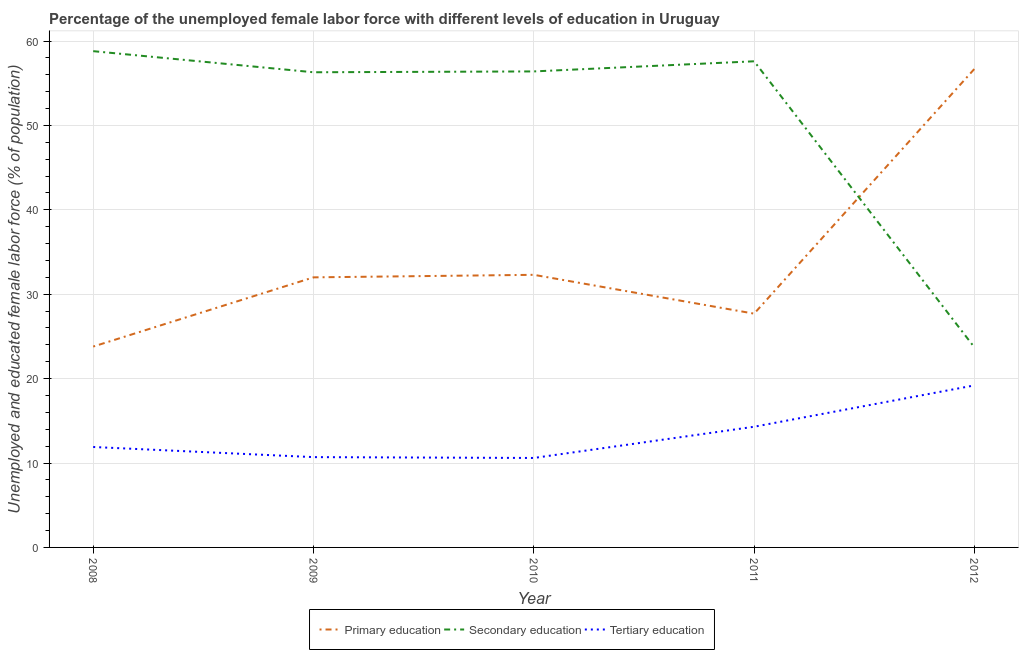How many different coloured lines are there?
Offer a terse response. 3. Does the line corresponding to percentage of female labor force who received primary education intersect with the line corresponding to percentage of female labor force who received secondary education?
Provide a succinct answer. Yes. What is the percentage of female labor force who received primary education in 2010?
Your answer should be compact. 32.3. Across all years, what is the maximum percentage of female labor force who received tertiary education?
Offer a terse response. 19.2. Across all years, what is the minimum percentage of female labor force who received secondary education?
Provide a succinct answer. 23.7. In which year was the percentage of female labor force who received primary education maximum?
Give a very brief answer. 2012. In which year was the percentage of female labor force who received secondary education minimum?
Provide a short and direct response. 2012. What is the total percentage of female labor force who received secondary education in the graph?
Your answer should be very brief. 252.8. What is the difference between the percentage of female labor force who received tertiary education in 2010 and that in 2012?
Your answer should be very brief. -8.6. What is the difference between the percentage of female labor force who received primary education in 2012 and the percentage of female labor force who received secondary education in 2009?
Provide a succinct answer. 0.4. What is the average percentage of female labor force who received primary education per year?
Provide a short and direct response. 34.5. In the year 2011, what is the difference between the percentage of female labor force who received secondary education and percentage of female labor force who received tertiary education?
Provide a short and direct response. 43.3. In how many years, is the percentage of female labor force who received primary education greater than 20 %?
Your answer should be very brief. 5. What is the ratio of the percentage of female labor force who received tertiary education in 2008 to that in 2009?
Provide a short and direct response. 1.11. Is the difference between the percentage of female labor force who received tertiary education in 2008 and 2009 greater than the difference between the percentage of female labor force who received secondary education in 2008 and 2009?
Make the answer very short. No. What is the difference between the highest and the second highest percentage of female labor force who received primary education?
Provide a short and direct response. 24.4. What is the difference between the highest and the lowest percentage of female labor force who received secondary education?
Keep it short and to the point. 35.1. How many lines are there?
Your response must be concise. 3. How many years are there in the graph?
Keep it short and to the point. 5. Are the values on the major ticks of Y-axis written in scientific E-notation?
Make the answer very short. No. How are the legend labels stacked?
Offer a very short reply. Horizontal. What is the title of the graph?
Your answer should be compact. Percentage of the unemployed female labor force with different levels of education in Uruguay. What is the label or title of the X-axis?
Provide a short and direct response. Year. What is the label or title of the Y-axis?
Make the answer very short. Unemployed and educated female labor force (% of population). What is the Unemployed and educated female labor force (% of population) in Primary education in 2008?
Your answer should be compact. 23.8. What is the Unemployed and educated female labor force (% of population) of Secondary education in 2008?
Provide a succinct answer. 58.8. What is the Unemployed and educated female labor force (% of population) of Tertiary education in 2008?
Offer a terse response. 11.9. What is the Unemployed and educated female labor force (% of population) in Secondary education in 2009?
Provide a succinct answer. 56.3. What is the Unemployed and educated female labor force (% of population) in Tertiary education in 2009?
Offer a very short reply. 10.7. What is the Unemployed and educated female labor force (% of population) of Primary education in 2010?
Provide a succinct answer. 32.3. What is the Unemployed and educated female labor force (% of population) of Secondary education in 2010?
Keep it short and to the point. 56.4. What is the Unemployed and educated female labor force (% of population) in Tertiary education in 2010?
Offer a very short reply. 10.6. What is the Unemployed and educated female labor force (% of population) in Primary education in 2011?
Keep it short and to the point. 27.7. What is the Unemployed and educated female labor force (% of population) of Secondary education in 2011?
Keep it short and to the point. 57.6. What is the Unemployed and educated female labor force (% of population) of Tertiary education in 2011?
Your response must be concise. 14.3. What is the Unemployed and educated female labor force (% of population) in Primary education in 2012?
Offer a terse response. 56.7. What is the Unemployed and educated female labor force (% of population) in Secondary education in 2012?
Give a very brief answer. 23.7. What is the Unemployed and educated female labor force (% of population) in Tertiary education in 2012?
Your answer should be compact. 19.2. Across all years, what is the maximum Unemployed and educated female labor force (% of population) in Primary education?
Provide a short and direct response. 56.7. Across all years, what is the maximum Unemployed and educated female labor force (% of population) in Secondary education?
Offer a very short reply. 58.8. Across all years, what is the maximum Unemployed and educated female labor force (% of population) in Tertiary education?
Offer a very short reply. 19.2. Across all years, what is the minimum Unemployed and educated female labor force (% of population) of Primary education?
Give a very brief answer. 23.8. Across all years, what is the minimum Unemployed and educated female labor force (% of population) in Secondary education?
Give a very brief answer. 23.7. Across all years, what is the minimum Unemployed and educated female labor force (% of population) of Tertiary education?
Your answer should be very brief. 10.6. What is the total Unemployed and educated female labor force (% of population) of Primary education in the graph?
Give a very brief answer. 172.5. What is the total Unemployed and educated female labor force (% of population) in Secondary education in the graph?
Your answer should be very brief. 252.8. What is the total Unemployed and educated female labor force (% of population) in Tertiary education in the graph?
Your response must be concise. 66.7. What is the difference between the Unemployed and educated female labor force (% of population) of Primary education in 2008 and that in 2009?
Provide a short and direct response. -8.2. What is the difference between the Unemployed and educated female labor force (% of population) in Secondary education in 2008 and that in 2009?
Provide a succinct answer. 2.5. What is the difference between the Unemployed and educated female labor force (% of population) in Secondary education in 2008 and that in 2010?
Your response must be concise. 2.4. What is the difference between the Unemployed and educated female labor force (% of population) of Tertiary education in 2008 and that in 2010?
Provide a short and direct response. 1.3. What is the difference between the Unemployed and educated female labor force (% of population) of Tertiary education in 2008 and that in 2011?
Your response must be concise. -2.4. What is the difference between the Unemployed and educated female labor force (% of population) in Primary education in 2008 and that in 2012?
Offer a terse response. -32.9. What is the difference between the Unemployed and educated female labor force (% of population) of Secondary education in 2008 and that in 2012?
Your response must be concise. 35.1. What is the difference between the Unemployed and educated female labor force (% of population) in Tertiary education in 2008 and that in 2012?
Your answer should be compact. -7.3. What is the difference between the Unemployed and educated female labor force (% of population) of Secondary education in 2009 and that in 2011?
Give a very brief answer. -1.3. What is the difference between the Unemployed and educated female labor force (% of population) of Tertiary education in 2009 and that in 2011?
Make the answer very short. -3.6. What is the difference between the Unemployed and educated female labor force (% of population) in Primary education in 2009 and that in 2012?
Keep it short and to the point. -24.7. What is the difference between the Unemployed and educated female labor force (% of population) in Secondary education in 2009 and that in 2012?
Make the answer very short. 32.6. What is the difference between the Unemployed and educated female labor force (% of population) of Primary education in 2010 and that in 2012?
Keep it short and to the point. -24.4. What is the difference between the Unemployed and educated female labor force (% of population) of Secondary education in 2010 and that in 2012?
Provide a short and direct response. 32.7. What is the difference between the Unemployed and educated female labor force (% of population) of Tertiary education in 2010 and that in 2012?
Offer a terse response. -8.6. What is the difference between the Unemployed and educated female labor force (% of population) of Primary education in 2011 and that in 2012?
Offer a terse response. -29. What is the difference between the Unemployed and educated female labor force (% of population) of Secondary education in 2011 and that in 2012?
Your answer should be compact. 33.9. What is the difference between the Unemployed and educated female labor force (% of population) of Tertiary education in 2011 and that in 2012?
Make the answer very short. -4.9. What is the difference between the Unemployed and educated female labor force (% of population) of Primary education in 2008 and the Unemployed and educated female labor force (% of population) of Secondary education in 2009?
Offer a very short reply. -32.5. What is the difference between the Unemployed and educated female labor force (% of population) of Secondary education in 2008 and the Unemployed and educated female labor force (% of population) of Tertiary education in 2009?
Make the answer very short. 48.1. What is the difference between the Unemployed and educated female labor force (% of population) of Primary education in 2008 and the Unemployed and educated female labor force (% of population) of Secondary education in 2010?
Give a very brief answer. -32.6. What is the difference between the Unemployed and educated female labor force (% of population) in Primary education in 2008 and the Unemployed and educated female labor force (% of population) in Tertiary education in 2010?
Give a very brief answer. 13.2. What is the difference between the Unemployed and educated female labor force (% of population) in Secondary education in 2008 and the Unemployed and educated female labor force (% of population) in Tertiary education in 2010?
Your response must be concise. 48.2. What is the difference between the Unemployed and educated female labor force (% of population) in Primary education in 2008 and the Unemployed and educated female labor force (% of population) in Secondary education in 2011?
Ensure brevity in your answer.  -33.8. What is the difference between the Unemployed and educated female labor force (% of population) of Primary education in 2008 and the Unemployed and educated female labor force (% of population) of Tertiary education in 2011?
Provide a short and direct response. 9.5. What is the difference between the Unemployed and educated female labor force (% of population) of Secondary education in 2008 and the Unemployed and educated female labor force (% of population) of Tertiary education in 2011?
Keep it short and to the point. 44.5. What is the difference between the Unemployed and educated female labor force (% of population) of Primary education in 2008 and the Unemployed and educated female labor force (% of population) of Secondary education in 2012?
Your response must be concise. 0.1. What is the difference between the Unemployed and educated female labor force (% of population) in Primary education in 2008 and the Unemployed and educated female labor force (% of population) in Tertiary education in 2012?
Your answer should be compact. 4.6. What is the difference between the Unemployed and educated female labor force (% of population) in Secondary education in 2008 and the Unemployed and educated female labor force (% of population) in Tertiary education in 2012?
Ensure brevity in your answer.  39.6. What is the difference between the Unemployed and educated female labor force (% of population) of Primary education in 2009 and the Unemployed and educated female labor force (% of population) of Secondary education in 2010?
Keep it short and to the point. -24.4. What is the difference between the Unemployed and educated female labor force (% of population) of Primary education in 2009 and the Unemployed and educated female labor force (% of population) of Tertiary education in 2010?
Offer a very short reply. 21.4. What is the difference between the Unemployed and educated female labor force (% of population) of Secondary education in 2009 and the Unemployed and educated female labor force (% of population) of Tertiary education in 2010?
Provide a short and direct response. 45.7. What is the difference between the Unemployed and educated female labor force (% of population) of Primary education in 2009 and the Unemployed and educated female labor force (% of population) of Secondary education in 2011?
Make the answer very short. -25.6. What is the difference between the Unemployed and educated female labor force (% of population) in Primary education in 2009 and the Unemployed and educated female labor force (% of population) in Tertiary education in 2011?
Make the answer very short. 17.7. What is the difference between the Unemployed and educated female labor force (% of population) of Primary education in 2009 and the Unemployed and educated female labor force (% of population) of Secondary education in 2012?
Your answer should be compact. 8.3. What is the difference between the Unemployed and educated female labor force (% of population) of Primary education in 2009 and the Unemployed and educated female labor force (% of population) of Tertiary education in 2012?
Your response must be concise. 12.8. What is the difference between the Unemployed and educated female labor force (% of population) in Secondary education in 2009 and the Unemployed and educated female labor force (% of population) in Tertiary education in 2012?
Offer a terse response. 37.1. What is the difference between the Unemployed and educated female labor force (% of population) in Primary education in 2010 and the Unemployed and educated female labor force (% of population) in Secondary education in 2011?
Your answer should be very brief. -25.3. What is the difference between the Unemployed and educated female labor force (% of population) in Secondary education in 2010 and the Unemployed and educated female labor force (% of population) in Tertiary education in 2011?
Keep it short and to the point. 42.1. What is the difference between the Unemployed and educated female labor force (% of population) in Secondary education in 2010 and the Unemployed and educated female labor force (% of population) in Tertiary education in 2012?
Offer a terse response. 37.2. What is the difference between the Unemployed and educated female labor force (% of population) in Secondary education in 2011 and the Unemployed and educated female labor force (% of population) in Tertiary education in 2012?
Make the answer very short. 38.4. What is the average Unemployed and educated female labor force (% of population) of Primary education per year?
Your response must be concise. 34.5. What is the average Unemployed and educated female labor force (% of population) in Secondary education per year?
Your response must be concise. 50.56. What is the average Unemployed and educated female labor force (% of population) in Tertiary education per year?
Ensure brevity in your answer.  13.34. In the year 2008, what is the difference between the Unemployed and educated female labor force (% of population) of Primary education and Unemployed and educated female labor force (% of population) of Secondary education?
Provide a short and direct response. -35. In the year 2008, what is the difference between the Unemployed and educated female labor force (% of population) of Primary education and Unemployed and educated female labor force (% of population) of Tertiary education?
Your response must be concise. 11.9. In the year 2008, what is the difference between the Unemployed and educated female labor force (% of population) in Secondary education and Unemployed and educated female labor force (% of population) in Tertiary education?
Offer a very short reply. 46.9. In the year 2009, what is the difference between the Unemployed and educated female labor force (% of population) of Primary education and Unemployed and educated female labor force (% of population) of Secondary education?
Offer a very short reply. -24.3. In the year 2009, what is the difference between the Unemployed and educated female labor force (% of population) of Primary education and Unemployed and educated female labor force (% of population) of Tertiary education?
Keep it short and to the point. 21.3. In the year 2009, what is the difference between the Unemployed and educated female labor force (% of population) of Secondary education and Unemployed and educated female labor force (% of population) of Tertiary education?
Offer a very short reply. 45.6. In the year 2010, what is the difference between the Unemployed and educated female labor force (% of population) in Primary education and Unemployed and educated female labor force (% of population) in Secondary education?
Provide a short and direct response. -24.1. In the year 2010, what is the difference between the Unemployed and educated female labor force (% of population) of Primary education and Unemployed and educated female labor force (% of population) of Tertiary education?
Keep it short and to the point. 21.7. In the year 2010, what is the difference between the Unemployed and educated female labor force (% of population) in Secondary education and Unemployed and educated female labor force (% of population) in Tertiary education?
Ensure brevity in your answer.  45.8. In the year 2011, what is the difference between the Unemployed and educated female labor force (% of population) in Primary education and Unemployed and educated female labor force (% of population) in Secondary education?
Provide a succinct answer. -29.9. In the year 2011, what is the difference between the Unemployed and educated female labor force (% of population) in Secondary education and Unemployed and educated female labor force (% of population) in Tertiary education?
Offer a terse response. 43.3. In the year 2012, what is the difference between the Unemployed and educated female labor force (% of population) of Primary education and Unemployed and educated female labor force (% of population) of Tertiary education?
Your answer should be compact. 37.5. In the year 2012, what is the difference between the Unemployed and educated female labor force (% of population) in Secondary education and Unemployed and educated female labor force (% of population) in Tertiary education?
Keep it short and to the point. 4.5. What is the ratio of the Unemployed and educated female labor force (% of population) of Primary education in 2008 to that in 2009?
Ensure brevity in your answer.  0.74. What is the ratio of the Unemployed and educated female labor force (% of population) in Secondary education in 2008 to that in 2009?
Offer a terse response. 1.04. What is the ratio of the Unemployed and educated female labor force (% of population) of Tertiary education in 2008 to that in 2009?
Your answer should be compact. 1.11. What is the ratio of the Unemployed and educated female labor force (% of population) of Primary education in 2008 to that in 2010?
Your answer should be compact. 0.74. What is the ratio of the Unemployed and educated female labor force (% of population) in Secondary education in 2008 to that in 2010?
Provide a succinct answer. 1.04. What is the ratio of the Unemployed and educated female labor force (% of population) of Tertiary education in 2008 to that in 2010?
Your answer should be compact. 1.12. What is the ratio of the Unemployed and educated female labor force (% of population) in Primary education in 2008 to that in 2011?
Your answer should be very brief. 0.86. What is the ratio of the Unemployed and educated female labor force (% of population) of Secondary education in 2008 to that in 2011?
Offer a terse response. 1.02. What is the ratio of the Unemployed and educated female labor force (% of population) of Tertiary education in 2008 to that in 2011?
Offer a very short reply. 0.83. What is the ratio of the Unemployed and educated female labor force (% of population) of Primary education in 2008 to that in 2012?
Provide a succinct answer. 0.42. What is the ratio of the Unemployed and educated female labor force (% of population) of Secondary education in 2008 to that in 2012?
Offer a terse response. 2.48. What is the ratio of the Unemployed and educated female labor force (% of population) of Tertiary education in 2008 to that in 2012?
Offer a terse response. 0.62. What is the ratio of the Unemployed and educated female labor force (% of population) of Secondary education in 2009 to that in 2010?
Provide a succinct answer. 1. What is the ratio of the Unemployed and educated female labor force (% of population) of Tertiary education in 2009 to that in 2010?
Your answer should be very brief. 1.01. What is the ratio of the Unemployed and educated female labor force (% of population) of Primary education in 2009 to that in 2011?
Keep it short and to the point. 1.16. What is the ratio of the Unemployed and educated female labor force (% of population) in Secondary education in 2009 to that in 2011?
Your response must be concise. 0.98. What is the ratio of the Unemployed and educated female labor force (% of population) in Tertiary education in 2009 to that in 2011?
Ensure brevity in your answer.  0.75. What is the ratio of the Unemployed and educated female labor force (% of population) of Primary education in 2009 to that in 2012?
Your answer should be very brief. 0.56. What is the ratio of the Unemployed and educated female labor force (% of population) of Secondary education in 2009 to that in 2012?
Ensure brevity in your answer.  2.38. What is the ratio of the Unemployed and educated female labor force (% of population) in Tertiary education in 2009 to that in 2012?
Your answer should be very brief. 0.56. What is the ratio of the Unemployed and educated female labor force (% of population) of Primary education in 2010 to that in 2011?
Offer a very short reply. 1.17. What is the ratio of the Unemployed and educated female labor force (% of population) of Secondary education in 2010 to that in 2011?
Provide a succinct answer. 0.98. What is the ratio of the Unemployed and educated female labor force (% of population) in Tertiary education in 2010 to that in 2011?
Your answer should be very brief. 0.74. What is the ratio of the Unemployed and educated female labor force (% of population) in Primary education in 2010 to that in 2012?
Ensure brevity in your answer.  0.57. What is the ratio of the Unemployed and educated female labor force (% of population) of Secondary education in 2010 to that in 2012?
Give a very brief answer. 2.38. What is the ratio of the Unemployed and educated female labor force (% of population) in Tertiary education in 2010 to that in 2012?
Offer a terse response. 0.55. What is the ratio of the Unemployed and educated female labor force (% of population) in Primary education in 2011 to that in 2012?
Offer a very short reply. 0.49. What is the ratio of the Unemployed and educated female labor force (% of population) in Secondary education in 2011 to that in 2012?
Make the answer very short. 2.43. What is the ratio of the Unemployed and educated female labor force (% of population) of Tertiary education in 2011 to that in 2012?
Offer a very short reply. 0.74. What is the difference between the highest and the second highest Unemployed and educated female labor force (% of population) of Primary education?
Your answer should be very brief. 24.4. What is the difference between the highest and the second highest Unemployed and educated female labor force (% of population) in Secondary education?
Your answer should be compact. 1.2. What is the difference between the highest and the lowest Unemployed and educated female labor force (% of population) in Primary education?
Offer a terse response. 32.9. What is the difference between the highest and the lowest Unemployed and educated female labor force (% of population) of Secondary education?
Offer a terse response. 35.1. 